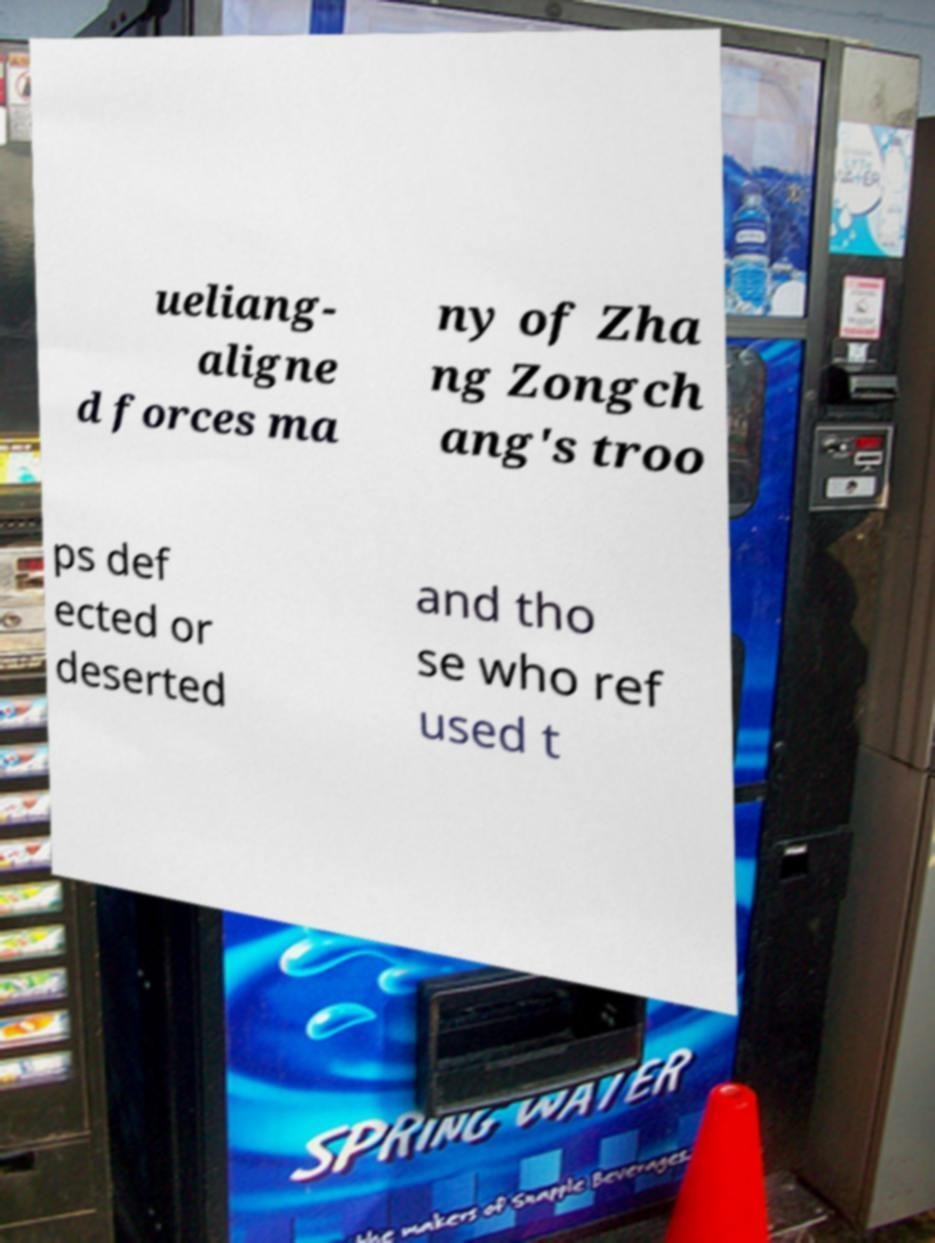Could you assist in decoding the text presented in this image and type it out clearly? ueliang- aligne d forces ma ny of Zha ng Zongch ang's troo ps def ected or deserted and tho se who ref used t 